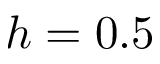Convert formula to latex. <formula><loc_0><loc_0><loc_500><loc_500>h = 0 . 5</formula> 